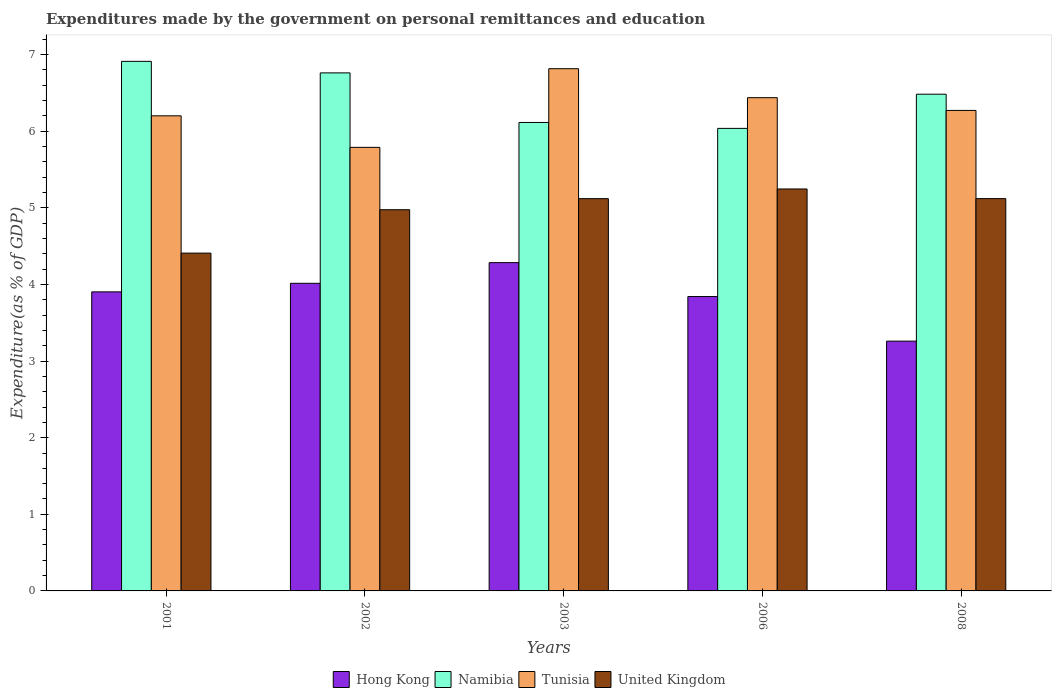How many different coloured bars are there?
Your answer should be compact. 4. How many bars are there on the 3rd tick from the right?
Your answer should be very brief. 4. In how many cases, is the number of bars for a given year not equal to the number of legend labels?
Keep it short and to the point. 0. What is the expenditures made by the government on personal remittances and education in Namibia in 2001?
Your answer should be very brief. 6.91. Across all years, what is the maximum expenditures made by the government on personal remittances and education in Tunisia?
Make the answer very short. 6.82. Across all years, what is the minimum expenditures made by the government on personal remittances and education in Hong Kong?
Your answer should be compact. 3.26. In which year was the expenditures made by the government on personal remittances and education in Hong Kong maximum?
Your answer should be compact. 2003. In which year was the expenditures made by the government on personal remittances and education in United Kingdom minimum?
Keep it short and to the point. 2001. What is the total expenditures made by the government on personal remittances and education in United Kingdom in the graph?
Ensure brevity in your answer.  24.87. What is the difference between the expenditures made by the government on personal remittances and education in Tunisia in 2008 and the expenditures made by the government on personal remittances and education in Namibia in 2001?
Keep it short and to the point. -0.64. What is the average expenditures made by the government on personal remittances and education in United Kingdom per year?
Provide a succinct answer. 4.97. In the year 2003, what is the difference between the expenditures made by the government on personal remittances and education in Namibia and expenditures made by the government on personal remittances and education in Hong Kong?
Offer a very short reply. 1.83. What is the ratio of the expenditures made by the government on personal remittances and education in Namibia in 2006 to that in 2008?
Keep it short and to the point. 0.93. Is the difference between the expenditures made by the government on personal remittances and education in Namibia in 2001 and 2002 greater than the difference between the expenditures made by the government on personal remittances and education in Hong Kong in 2001 and 2002?
Offer a terse response. Yes. What is the difference between the highest and the second highest expenditures made by the government on personal remittances and education in Tunisia?
Offer a very short reply. 0.38. What is the difference between the highest and the lowest expenditures made by the government on personal remittances and education in Hong Kong?
Provide a short and direct response. 1.02. Is it the case that in every year, the sum of the expenditures made by the government on personal remittances and education in Tunisia and expenditures made by the government on personal remittances and education in Hong Kong is greater than the sum of expenditures made by the government on personal remittances and education in United Kingdom and expenditures made by the government on personal remittances and education in Namibia?
Offer a very short reply. Yes. What does the 4th bar from the left in 2006 represents?
Your answer should be very brief. United Kingdom. What does the 3rd bar from the right in 2008 represents?
Your answer should be very brief. Namibia. Are all the bars in the graph horizontal?
Make the answer very short. No. Does the graph contain any zero values?
Provide a short and direct response. No. Does the graph contain grids?
Provide a succinct answer. No. How are the legend labels stacked?
Your response must be concise. Horizontal. What is the title of the graph?
Make the answer very short. Expenditures made by the government on personal remittances and education. Does "Seychelles" appear as one of the legend labels in the graph?
Give a very brief answer. No. What is the label or title of the X-axis?
Provide a short and direct response. Years. What is the label or title of the Y-axis?
Provide a succinct answer. Expenditure(as % of GDP). What is the Expenditure(as % of GDP) in Hong Kong in 2001?
Offer a very short reply. 3.9. What is the Expenditure(as % of GDP) in Namibia in 2001?
Keep it short and to the point. 6.91. What is the Expenditure(as % of GDP) in Tunisia in 2001?
Offer a very short reply. 6.2. What is the Expenditure(as % of GDP) in United Kingdom in 2001?
Provide a succinct answer. 4.41. What is the Expenditure(as % of GDP) in Hong Kong in 2002?
Your answer should be compact. 4.02. What is the Expenditure(as % of GDP) in Namibia in 2002?
Your answer should be very brief. 6.76. What is the Expenditure(as % of GDP) of Tunisia in 2002?
Provide a succinct answer. 5.79. What is the Expenditure(as % of GDP) of United Kingdom in 2002?
Provide a succinct answer. 4.98. What is the Expenditure(as % of GDP) in Hong Kong in 2003?
Your answer should be compact. 4.29. What is the Expenditure(as % of GDP) in Namibia in 2003?
Ensure brevity in your answer.  6.12. What is the Expenditure(as % of GDP) of Tunisia in 2003?
Your answer should be very brief. 6.82. What is the Expenditure(as % of GDP) of United Kingdom in 2003?
Offer a terse response. 5.12. What is the Expenditure(as % of GDP) in Hong Kong in 2006?
Make the answer very short. 3.84. What is the Expenditure(as % of GDP) in Namibia in 2006?
Offer a terse response. 6.04. What is the Expenditure(as % of GDP) of Tunisia in 2006?
Offer a very short reply. 6.44. What is the Expenditure(as % of GDP) of United Kingdom in 2006?
Offer a terse response. 5.25. What is the Expenditure(as % of GDP) of Hong Kong in 2008?
Make the answer very short. 3.26. What is the Expenditure(as % of GDP) of Namibia in 2008?
Give a very brief answer. 6.48. What is the Expenditure(as % of GDP) in Tunisia in 2008?
Offer a very short reply. 6.27. What is the Expenditure(as % of GDP) in United Kingdom in 2008?
Provide a succinct answer. 5.12. Across all years, what is the maximum Expenditure(as % of GDP) in Hong Kong?
Offer a very short reply. 4.29. Across all years, what is the maximum Expenditure(as % of GDP) of Namibia?
Give a very brief answer. 6.91. Across all years, what is the maximum Expenditure(as % of GDP) of Tunisia?
Provide a succinct answer. 6.82. Across all years, what is the maximum Expenditure(as % of GDP) of United Kingdom?
Give a very brief answer. 5.25. Across all years, what is the minimum Expenditure(as % of GDP) in Hong Kong?
Your answer should be very brief. 3.26. Across all years, what is the minimum Expenditure(as % of GDP) in Namibia?
Your response must be concise. 6.04. Across all years, what is the minimum Expenditure(as % of GDP) of Tunisia?
Your answer should be compact. 5.79. Across all years, what is the minimum Expenditure(as % of GDP) in United Kingdom?
Give a very brief answer. 4.41. What is the total Expenditure(as % of GDP) of Hong Kong in the graph?
Ensure brevity in your answer.  19.31. What is the total Expenditure(as % of GDP) in Namibia in the graph?
Your response must be concise. 32.31. What is the total Expenditure(as % of GDP) in Tunisia in the graph?
Your answer should be very brief. 31.52. What is the total Expenditure(as % of GDP) in United Kingdom in the graph?
Your answer should be very brief. 24.87. What is the difference between the Expenditure(as % of GDP) of Hong Kong in 2001 and that in 2002?
Offer a very short reply. -0.11. What is the difference between the Expenditure(as % of GDP) in Namibia in 2001 and that in 2002?
Make the answer very short. 0.15. What is the difference between the Expenditure(as % of GDP) in Tunisia in 2001 and that in 2002?
Keep it short and to the point. 0.41. What is the difference between the Expenditure(as % of GDP) in United Kingdom in 2001 and that in 2002?
Provide a succinct answer. -0.57. What is the difference between the Expenditure(as % of GDP) in Hong Kong in 2001 and that in 2003?
Provide a succinct answer. -0.38. What is the difference between the Expenditure(as % of GDP) in Namibia in 2001 and that in 2003?
Keep it short and to the point. 0.8. What is the difference between the Expenditure(as % of GDP) of Tunisia in 2001 and that in 2003?
Offer a very short reply. -0.61. What is the difference between the Expenditure(as % of GDP) of United Kingdom in 2001 and that in 2003?
Keep it short and to the point. -0.71. What is the difference between the Expenditure(as % of GDP) in Hong Kong in 2001 and that in 2006?
Keep it short and to the point. 0.06. What is the difference between the Expenditure(as % of GDP) in Tunisia in 2001 and that in 2006?
Keep it short and to the point. -0.24. What is the difference between the Expenditure(as % of GDP) of United Kingdom in 2001 and that in 2006?
Your answer should be very brief. -0.84. What is the difference between the Expenditure(as % of GDP) in Hong Kong in 2001 and that in 2008?
Make the answer very short. 0.64. What is the difference between the Expenditure(as % of GDP) of Namibia in 2001 and that in 2008?
Your response must be concise. 0.43. What is the difference between the Expenditure(as % of GDP) in Tunisia in 2001 and that in 2008?
Give a very brief answer. -0.07. What is the difference between the Expenditure(as % of GDP) of United Kingdom in 2001 and that in 2008?
Your response must be concise. -0.71. What is the difference between the Expenditure(as % of GDP) of Hong Kong in 2002 and that in 2003?
Make the answer very short. -0.27. What is the difference between the Expenditure(as % of GDP) of Namibia in 2002 and that in 2003?
Ensure brevity in your answer.  0.65. What is the difference between the Expenditure(as % of GDP) of Tunisia in 2002 and that in 2003?
Provide a succinct answer. -1.03. What is the difference between the Expenditure(as % of GDP) in United Kingdom in 2002 and that in 2003?
Provide a succinct answer. -0.14. What is the difference between the Expenditure(as % of GDP) in Hong Kong in 2002 and that in 2006?
Offer a very short reply. 0.17. What is the difference between the Expenditure(as % of GDP) in Namibia in 2002 and that in 2006?
Your answer should be compact. 0.72. What is the difference between the Expenditure(as % of GDP) of Tunisia in 2002 and that in 2006?
Your answer should be very brief. -0.65. What is the difference between the Expenditure(as % of GDP) in United Kingdom in 2002 and that in 2006?
Provide a succinct answer. -0.27. What is the difference between the Expenditure(as % of GDP) in Hong Kong in 2002 and that in 2008?
Make the answer very short. 0.75. What is the difference between the Expenditure(as % of GDP) in Namibia in 2002 and that in 2008?
Keep it short and to the point. 0.28. What is the difference between the Expenditure(as % of GDP) in Tunisia in 2002 and that in 2008?
Keep it short and to the point. -0.48. What is the difference between the Expenditure(as % of GDP) of United Kingdom in 2002 and that in 2008?
Your answer should be compact. -0.14. What is the difference between the Expenditure(as % of GDP) of Hong Kong in 2003 and that in 2006?
Your response must be concise. 0.44. What is the difference between the Expenditure(as % of GDP) of Namibia in 2003 and that in 2006?
Give a very brief answer. 0.08. What is the difference between the Expenditure(as % of GDP) of Tunisia in 2003 and that in 2006?
Provide a short and direct response. 0.38. What is the difference between the Expenditure(as % of GDP) of United Kingdom in 2003 and that in 2006?
Your response must be concise. -0.13. What is the difference between the Expenditure(as % of GDP) in Hong Kong in 2003 and that in 2008?
Provide a short and direct response. 1.02. What is the difference between the Expenditure(as % of GDP) in Namibia in 2003 and that in 2008?
Offer a terse response. -0.37. What is the difference between the Expenditure(as % of GDP) in Tunisia in 2003 and that in 2008?
Your answer should be compact. 0.54. What is the difference between the Expenditure(as % of GDP) in United Kingdom in 2003 and that in 2008?
Your answer should be very brief. -0. What is the difference between the Expenditure(as % of GDP) of Hong Kong in 2006 and that in 2008?
Offer a very short reply. 0.58. What is the difference between the Expenditure(as % of GDP) of Namibia in 2006 and that in 2008?
Ensure brevity in your answer.  -0.45. What is the difference between the Expenditure(as % of GDP) in Tunisia in 2006 and that in 2008?
Offer a very short reply. 0.17. What is the difference between the Expenditure(as % of GDP) in United Kingdom in 2006 and that in 2008?
Ensure brevity in your answer.  0.13. What is the difference between the Expenditure(as % of GDP) in Hong Kong in 2001 and the Expenditure(as % of GDP) in Namibia in 2002?
Your response must be concise. -2.86. What is the difference between the Expenditure(as % of GDP) in Hong Kong in 2001 and the Expenditure(as % of GDP) in Tunisia in 2002?
Give a very brief answer. -1.89. What is the difference between the Expenditure(as % of GDP) in Hong Kong in 2001 and the Expenditure(as % of GDP) in United Kingdom in 2002?
Offer a very short reply. -1.07. What is the difference between the Expenditure(as % of GDP) of Namibia in 2001 and the Expenditure(as % of GDP) of Tunisia in 2002?
Offer a terse response. 1.12. What is the difference between the Expenditure(as % of GDP) in Namibia in 2001 and the Expenditure(as % of GDP) in United Kingdom in 2002?
Your response must be concise. 1.94. What is the difference between the Expenditure(as % of GDP) in Tunisia in 2001 and the Expenditure(as % of GDP) in United Kingdom in 2002?
Provide a succinct answer. 1.23. What is the difference between the Expenditure(as % of GDP) of Hong Kong in 2001 and the Expenditure(as % of GDP) of Namibia in 2003?
Provide a short and direct response. -2.21. What is the difference between the Expenditure(as % of GDP) in Hong Kong in 2001 and the Expenditure(as % of GDP) in Tunisia in 2003?
Your answer should be very brief. -2.91. What is the difference between the Expenditure(as % of GDP) in Hong Kong in 2001 and the Expenditure(as % of GDP) in United Kingdom in 2003?
Your answer should be very brief. -1.22. What is the difference between the Expenditure(as % of GDP) of Namibia in 2001 and the Expenditure(as % of GDP) of Tunisia in 2003?
Your answer should be compact. 0.1. What is the difference between the Expenditure(as % of GDP) in Namibia in 2001 and the Expenditure(as % of GDP) in United Kingdom in 2003?
Give a very brief answer. 1.79. What is the difference between the Expenditure(as % of GDP) in Tunisia in 2001 and the Expenditure(as % of GDP) in United Kingdom in 2003?
Your response must be concise. 1.08. What is the difference between the Expenditure(as % of GDP) in Hong Kong in 2001 and the Expenditure(as % of GDP) in Namibia in 2006?
Provide a succinct answer. -2.13. What is the difference between the Expenditure(as % of GDP) of Hong Kong in 2001 and the Expenditure(as % of GDP) of Tunisia in 2006?
Your answer should be very brief. -2.53. What is the difference between the Expenditure(as % of GDP) in Hong Kong in 2001 and the Expenditure(as % of GDP) in United Kingdom in 2006?
Your answer should be very brief. -1.34. What is the difference between the Expenditure(as % of GDP) of Namibia in 2001 and the Expenditure(as % of GDP) of Tunisia in 2006?
Provide a short and direct response. 0.47. What is the difference between the Expenditure(as % of GDP) of Namibia in 2001 and the Expenditure(as % of GDP) of United Kingdom in 2006?
Keep it short and to the point. 1.67. What is the difference between the Expenditure(as % of GDP) of Tunisia in 2001 and the Expenditure(as % of GDP) of United Kingdom in 2006?
Your answer should be compact. 0.95. What is the difference between the Expenditure(as % of GDP) of Hong Kong in 2001 and the Expenditure(as % of GDP) of Namibia in 2008?
Your answer should be very brief. -2.58. What is the difference between the Expenditure(as % of GDP) in Hong Kong in 2001 and the Expenditure(as % of GDP) in Tunisia in 2008?
Make the answer very short. -2.37. What is the difference between the Expenditure(as % of GDP) of Hong Kong in 2001 and the Expenditure(as % of GDP) of United Kingdom in 2008?
Your answer should be compact. -1.22. What is the difference between the Expenditure(as % of GDP) in Namibia in 2001 and the Expenditure(as % of GDP) in Tunisia in 2008?
Your response must be concise. 0.64. What is the difference between the Expenditure(as % of GDP) in Namibia in 2001 and the Expenditure(as % of GDP) in United Kingdom in 2008?
Provide a short and direct response. 1.79. What is the difference between the Expenditure(as % of GDP) of Tunisia in 2001 and the Expenditure(as % of GDP) of United Kingdom in 2008?
Offer a terse response. 1.08. What is the difference between the Expenditure(as % of GDP) of Hong Kong in 2002 and the Expenditure(as % of GDP) of Namibia in 2003?
Provide a succinct answer. -2.1. What is the difference between the Expenditure(as % of GDP) of Hong Kong in 2002 and the Expenditure(as % of GDP) of Tunisia in 2003?
Provide a short and direct response. -2.8. What is the difference between the Expenditure(as % of GDP) in Hong Kong in 2002 and the Expenditure(as % of GDP) in United Kingdom in 2003?
Keep it short and to the point. -1.1. What is the difference between the Expenditure(as % of GDP) of Namibia in 2002 and the Expenditure(as % of GDP) of Tunisia in 2003?
Make the answer very short. -0.05. What is the difference between the Expenditure(as % of GDP) in Namibia in 2002 and the Expenditure(as % of GDP) in United Kingdom in 2003?
Your answer should be very brief. 1.64. What is the difference between the Expenditure(as % of GDP) in Tunisia in 2002 and the Expenditure(as % of GDP) in United Kingdom in 2003?
Ensure brevity in your answer.  0.67. What is the difference between the Expenditure(as % of GDP) in Hong Kong in 2002 and the Expenditure(as % of GDP) in Namibia in 2006?
Provide a succinct answer. -2.02. What is the difference between the Expenditure(as % of GDP) in Hong Kong in 2002 and the Expenditure(as % of GDP) in Tunisia in 2006?
Make the answer very short. -2.42. What is the difference between the Expenditure(as % of GDP) in Hong Kong in 2002 and the Expenditure(as % of GDP) in United Kingdom in 2006?
Offer a very short reply. -1.23. What is the difference between the Expenditure(as % of GDP) of Namibia in 2002 and the Expenditure(as % of GDP) of Tunisia in 2006?
Your response must be concise. 0.32. What is the difference between the Expenditure(as % of GDP) of Namibia in 2002 and the Expenditure(as % of GDP) of United Kingdom in 2006?
Offer a terse response. 1.52. What is the difference between the Expenditure(as % of GDP) of Tunisia in 2002 and the Expenditure(as % of GDP) of United Kingdom in 2006?
Provide a succinct answer. 0.54. What is the difference between the Expenditure(as % of GDP) of Hong Kong in 2002 and the Expenditure(as % of GDP) of Namibia in 2008?
Your response must be concise. -2.47. What is the difference between the Expenditure(as % of GDP) in Hong Kong in 2002 and the Expenditure(as % of GDP) in Tunisia in 2008?
Provide a succinct answer. -2.26. What is the difference between the Expenditure(as % of GDP) of Hong Kong in 2002 and the Expenditure(as % of GDP) of United Kingdom in 2008?
Your response must be concise. -1.11. What is the difference between the Expenditure(as % of GDP) of Namibia in 2002 and the Expenditure(as % of GDP) of Tunisia in 2008?
Your response must be concise. 0.49. What is the difference between the Expenditure(as % of GDP) in Namibia in 2002 and the Expenditure(as % of GDP) in United Kingdom in 2008?
Offer a terse response. 1.64. What is the difference between the Expenditure(as % of GDP) of Tunisia in 2002 and the Expenditure(as % of GDP) of United Kingdom in 2008?
Make the answer very short. 0.67. What is the difference between the Expenditure(as % of GDP) in Hong Kong in 2003 and the Expenditure(as % of GDP) in Namibia in 2006?
Provide a short and direct response. -1.75. What is the difference between the Expenditure(as % of GDP) of Hong Kong in 2003 and the Expenditure(as % of GDP) of Tunisia in 2006?
Your response must be concise. -2.15. What is the difference between the Expenditure(as % of GDP) of Hong Kong in 2003 and the Expenditure(as % of GDP) of United Kingdom in 2006?
Your answer should be compact. -0.96. What is the difference between the Expenditure(as % of GDP) in Namibia in 2003 and the Expenditure(as % of GDP) in Tunisia in 2006?
Provide a short and direct response. -0.32. What is the difference between the Expenditure(as % of GDP) of Namibia in 2003 and the Expenditure(as % of GDP) of United Kingdom in 2006?
Make the answer very short. 0.87. What is the difference between the Expenditure(as % of GDP) in Tunisia in 2003 and the Expenditure(as % of GDP) in United Kingdom in 2006?
Your answer should be very brief. 1.57. What is the difference between the Expenditure(as % of GDP) of Hong Kong in 2003 and the Expenditure(as % of GDP) of Namibia in 2008?
Your answer should be compact. -2.2. What is the difference between the Expenditure(as % of GDP) in Hong Kong in 2003 and the Expenditure(as % of GDP) in Tunisia in 2008?
Keep it short and to the point. -1.99. What is the difference between the Expenditure(as % of GDP) in Hong Kong in 2003 and the Expenditure(as % of GDP) in United Kingdom in 2008?
Your answer should be very brief. -0.84. What is the difference between the Expenditure(as % of GDP) of Namibia in 2003 and the Expenditure(as % of GDP) of Tunisia in 2008?
Your answer should be very brief. -0.16. What is the difference between the Expenditure(as % of GDP) of Tunisia in 2003 and the Expenditure(as % of GDP) of United Kingdom in 2008?
Ensure brevity in your answer.  1.7. What is the difference between the Expenditure(as % of GDP) of Hong Kong in 2006 and the Expenditure(as % of GDP) of Namibia in 2008?
Keep it short and to the point. -2.64. What is the difference between the Expenditure(as % of GDP) in Hong Kong in 2006 and the Expenditure(as % of GDP) in Tunisia in 2008?
Keep it short and to the point. -2.43. What is the difference between the Expenditure(as % of GDP) in Hong Kong in 2006 and the Expenditure(as % of GDP) in United Kingdom in 2008?
Make the answer very short. -1.28. What is the difference between the Expenditure(as % of GDP) in Namibia in 2006 and the Expenditure(as % of GDP) in Tunisia in 2008?
Make the answer very short. -0.23. What is the difference between the Expenditure(as % of GDP) of Namibia in 2006 and the Expenditure(as % of GDP) of United Kingdom in 2008?
Keep it short and to the point. 0.92. What is the difference between the Expenditure(as % of GDP) in Tunisia in 2006 and the Expenditure(as % of GDP) in United Kingdom in 2008?
Keep it short and to the point. 1.32. What is the average Expenditure(as % of GDP) of Hong Kong per year?
Offer a terse response. 3.86. What is the average Expenditure(as % of GDP) of Namibia per year?
Offer a terse response. 6.46. What is the average Expenditure(as % of GDP) of Tunisia per year?
Your answer should be compact. 6.3. What is the average Expenditure(as % of GDP) in United Kingdom per year?
Your answer should be very brief. 4.97. In the year 2001, what is the difference between the Expenditure(as % of GDP) in Hong Kong and Expenditure(as % of GDP) in Namibia?
Give a very brief answer. -3.01. In the year 2001, what is the difference between the Expenditure(as % of GDP) of Hong Kong and Expenditure(as % of GDP) of Tunisia?
Your answer should be very brief. -2.3. In the year 2001, what is the difference between the Expenditure(as % of GDP) of Hong Kong and Expenditure(as % of GDP) of United Kingdom?
Keep it short and to the point. -0.51. In the year 2001, what is the difference between the Expenditure(as % of GDP) of Namibia and Expenditure(as % of GDP) of Tunisia?
Offer a very short reply. 0.71. In the year 2001, what is the difference between the Expenditure(as % of GDP) of Namibia and Expenditure(as % of GDP) of United Kingdom?
Offer a very short reply. 2.5. In the year 2001, what is the difference between the Expenditure(as % of GDP) in Tunisia and Expenditure(as % of GDP) in United Kingdom?
Your response must be concise. 1.79. In the year 2002, what is the difference between the Expenditure(as % of GDP) of Hong Kong and Expenditure(as % of GDP) of Namibia?
Provide a short and direct response. -2.75. In the year 2002, what is the difference between the Expenditure(as % of GDP) of Hong Kong and Expenditure(as % of GDP) of Tunisia?
Make the answer very short. -1.77. In the year 2002, what is the difference between the Expenditure(as % of GDP) of Hong Kong and Expenditure(as % of GDP) of United Kingdom?
Provide a succinct answer. -0.96. In the year 2002, what is the difference between the Expenditure(as % of GDP) in Namibia and Expenditure(as % of GDP) in Tunisia?
Provide a succinct answer. 0.97. In the year 2002, what is the difference between the Expenditure(as % of GDP) in Namibia and Expenditure(as % of GDP) in United Kingdom?
Ensure brevity in your answer.  1.79. In the year 2002, what is the difference between the Expenditure(as % of GDP) of Tunisia and Expenditure(as % of GDP) of United Kingdom?
Your answer should be very brief. 0.81. In the year 2003, what is the difference between the Expenditure(as % of GDP) of Hong Kong and Expenditure(as % of GDP) of Namibia?
Make the answer very short. -1.83. In the year 2003, what is the difference between the Expenditure(as % of GDP) in Hong Kong and Expenditure(as % of GDP) in Tunisia?
Provide a short and direct response. -2.53. In the year 2003, what is the difference between the Expenditure(as % of GDP) of Hong Kong and Expenditure(as % of GDP) of United Kingdom?
Keep it short and to the point. -0.84. In the year 2003, what is the difference between the Expenditure(as % of GDP) of Namibia and Expenditure(as % of GDP) of Tunisia?
Give a very brief answer. -0.7. In the year 2003, what is the difference between the Expenditure(as % of GDP) in Namibia and Expenditure(as % of GDP) in United Kingdom?
Provide a succinct answer. 0.99. In the year 2003, what is the difference between the Expenditure(as % of GDP) in Tunisia and Expenditure(as % of GDP) in United Kingdom?
Offer a terse response. 1.7. In the year 2006, what is the difference between the Expenditure(as % of GDP) of Hong Kong and Expenditure(as % of GDP) of Namibia?
Ensure brevity in your answer.  -2.19. In the year 2006, what is the difference between the Expenditure(as % of GDP) of Hong Kong and Expenditure(as % of GDP) of Tunisia?
Offer a very short reply. -2.6. In the year 2006, what is the difference between the Expenditure(as % of GDP) of Hong Kong and Expenditure(as % of GDP) of United Kingdom?
Your answer should be compact. -1.4. In the year 2006, what is the difference between the Expenditure(as % of GDP) of Namibia and Expenditure(as % of GDP) of Tunisia?
Offer a terse response. -0.4. In the year 2006, what is the difference between the Expenditure(as % of GDP) of Namibia and Expenditure(as % of GDP) of United Kingdom?
Provide a short and direct response. 0.79. In the year 2006, what is the difference between the Expenditure(as % of GDP) in Tunisia and Expenditure(as % of GDP) in United Kingdom?
Offer a very short reply. 1.19. In the year 2008, what is the difference between the Expenditure(as % of GDP) in Hong Kong and Expenditure(as % of GDP) in Namibia?
Provide a short and direct response. -3.22. In the year 2008, what is the difference between the Expenditure(as % of GDP) in Hong Kong and Expenditure(as % of GDP) in Tunisia?
Make the answer very short. -3.01. In the year 2008, what is the difference between the Expenditure(as % of GDP) in Hong Kong and Expenditure(as % of GDP) in United Kingdom?
Give a very brief answer. -1.86. In the year 2008, what is the difference between the Expenditure(as % of GDP) in Namibia and Expenditure(as % of GDP) in Tunisia?
Your answer should be compact. 0.21. In the year 2008, what is the difference between the Expenditure(as % of GDP) of Namibia and Expenditure(as % of GDP) of United Kingdom?
Provide a succinct answer. 1.36. In the year 2008, what is the difference between the Expenditure(as % of GDP) of Tunisia and Expenditure(as % of GDP) of United Kingdom?
Your answer should be very brief. 1.15. What is the ratio of the Expenditure(as % of GDP) in Hong Kong in 2001 to that in 2002?
Make the answer very short. 0.97. What is the ratio of the Expenditure(as % of GDP) of Namibia in 2001 to that in 2002?
Offer a terse response. 1.02. What is the ratio of the Expenditure(as % of GDP) in Tunisia in 2001 to that in 2002?
Provide a succinct answer. 1.07. What is the ratio of the Expenditure(as % of GDP) in United Kingdom in 2001 to that in 2002?
Offer a terse response. 0.89. What is the ratio of the Expenditure(as % of GDP) of Hong Kong in 2001 to that in 2003?
Your answer should be compact. 0.91. What is the ratio of the Expenditure(as % of GDP) of Namibia in 2001 to that in 2003?
Your answer should be compact. 1.13. What is the ratio of the Expenditure(as % of GDP) of Tunisia in 2001 to that in 2003?
Make the answer very short. 0.91. What is the ratio of the Expenditure(as % of GDP) in United Kingdom in 2001 to that in 2003?
Make the answer very short. 0.86. What is the ratio of the Expenditure(as % of GDP) in Hong Kong in 2001 to that in 2006?
Give a very brief answer. 1.02. What is the ratio of the Expenditure(as % of GDP) in Namibia in 2001 to that in 2006?
Give a very brief answer. 1.14. What is the ratio of the Expenditure(as % of GDP) of Tunisia in 2001 to that in 2006?
Make the answer very short. 0.96. What is the ratio of the Expenditure(as % of GDP) in United Kingdom in 2001 to that in 2006?
Provide a short and direct response. 0.84. What is the ratio of the Expenditure(as % of GDP) of Hong Kong in 2001 to that in 2008?
Offer a terse response. 1.2. What is the ratio of the Expenditure(as % of GDP) of Namibia in 2001 to that in 2008?
Your response must be concise. 1.07. What is the ratio of the Expenditure(as % of GDP) of Tunisia in 2001 to that in 2008?
Keep it short and to the point. 0.99. What is the ratio of the Expenditure(as % of GDP) of United Kingdom in 2001 to that in 2008?
Provide a short and direct response. 0.86. What is the ratio of the Expenditure(as % of GDP) of Hong Kong in 2002 to that in 2003?
Provide a succinct answer. 0.94. What is the ratio of the Expenditure(as % of GDP) in Namibia in 2002 to that in 2003?
Offer a very short reply. 1.11. What is the ratio of the Expenditure(as % of GDP) in Tunisia in 2002 to that in 2003?
Your answer should be compact. 0.85. What is the ratio of the Expenditure(as % of GDP) of United Kingdom in 2002 to that in 2003?
Keep it short and to the point. 0.97. What is the ratio of the Expenditure(as % of GDP) of Hong Kong in 2002 to that in 2006?
Your answer should be very brief. 1.04. What is the ratio of the Expenditure(as % of GDP) of Namibia in 2002 to that in 2006?
Ensure brevity in your answer.  1.12. What is the ratio of the Expenditure(as % of GDP) in Tunisia in 2002 to that in 2006?
Your answer should be compact. 0.9. What is the ratio of the Expenditure(as % of GDP) in United Kingdom in 2002 to that in 2006?
Give a very brief answer. 0.95. What is the ratio of the Expenditure(as % of GDP) of Hong Kong in 2002 to that in 2008?
Offer a terse response. 1.23. What is the ratio of the Expenditure(as % of GDP) of Namibia in 2002 to that in 2008?
Make the answer very short. 1.04. What is the ratio of the Expenditure(as % of GDP) in Tunisia in 2002 to that in 2008?
Offer a terse response. 0.92. What is the ratio of the Expenditure(as % of GDP) of United Kingdom in 2002 to that in 2008?
Your answer should be very brief. 0.97. What is the ratio of the Expenditure(as % of GDP) of Hong Kong in 2003 to that in 2006?
Ensure brevity in your answer.  1.12. What is the ratio of the Expenditure(as % of GDP) of Namibia in 2003 to that in 2006?
Keep it short and to the point. 1.01. What is the ratio of the Expenditure(as % of GDP) of Tunisia in 2003 to that in 2006?
Keep it short and to the point. 1.06. What is the ratio of the Expenditure(as % of GDP) of United Kingdom in 2003 to that in 2006?
Provide a succinct answer. 0.98. What is the ratio of the Expenditure(as % of GDP) in Hong Kong in 2003 to that in 2008?
Your answer should be compact. 1.31. What is the ratio of the Expenditure(as % of GDP) of Namibia in 2003 to that in 2008?
Offer a terse response. 0.94. What is the ratio of the Expenditure(as % of GDP) of Tunisia in 2003 to that in 2008?
Your response must be concise. 1.09. What is the ratio of the Expenditure(as % of GDP) in United Kingdom in 2003 to that in 2008?
Make the answer very short. 1. What is the ratio of the Expenditure(as % of GDP) of Hong Kong in 2006 to that in 2008?
Ensure brevity in your answer.  1.18. What is the ratio of the Expenditure(as % of GDP) in Namibia in 2006 to that in 2008?
Make the answer very short. 0.93. What is the ratio of the Expenditure(as % of GDP) of Tunisia in 2006 to that in 2008?
Provide a succinct answer. 1.03. What is the ratio of the Expenditure(as % of GDP) in United Kingdom in 2006 to that in 2008?
Offer a terse response. 1.02. What is the difference between the highest and the second highest Expenditure(as % of GDP) of Hong Kong?
Offer a very short reply. 0.27. What is the difference between the highest and the second highest Expenditure(as % of GDP) in Namibia?
Ensure brevity in your answer.  0.15. What is the difference between the highest and the second highest Expenditure(as % of GDP) in Tunisia?
Offer a terse response. 0.38. What is the difference between the highest and the second highest Expenditure(as % of GDP) of United Kingdom?
Ensure brevity in your answer.  0.13. What is the difference between the highest and the lowest Expenditure(as % of GDP) in Hong Kong?
Make the answer very short. 1.02. What is the difference between the highest and the lowest Expenditure(as % of GDP) of Tunisia?
Offer a very short reply. 1.03. What is the difference between the highest and the lowest Expenditure(as % of GDP) in United Kingdom?
Provide a succinct answer. 0.84. 